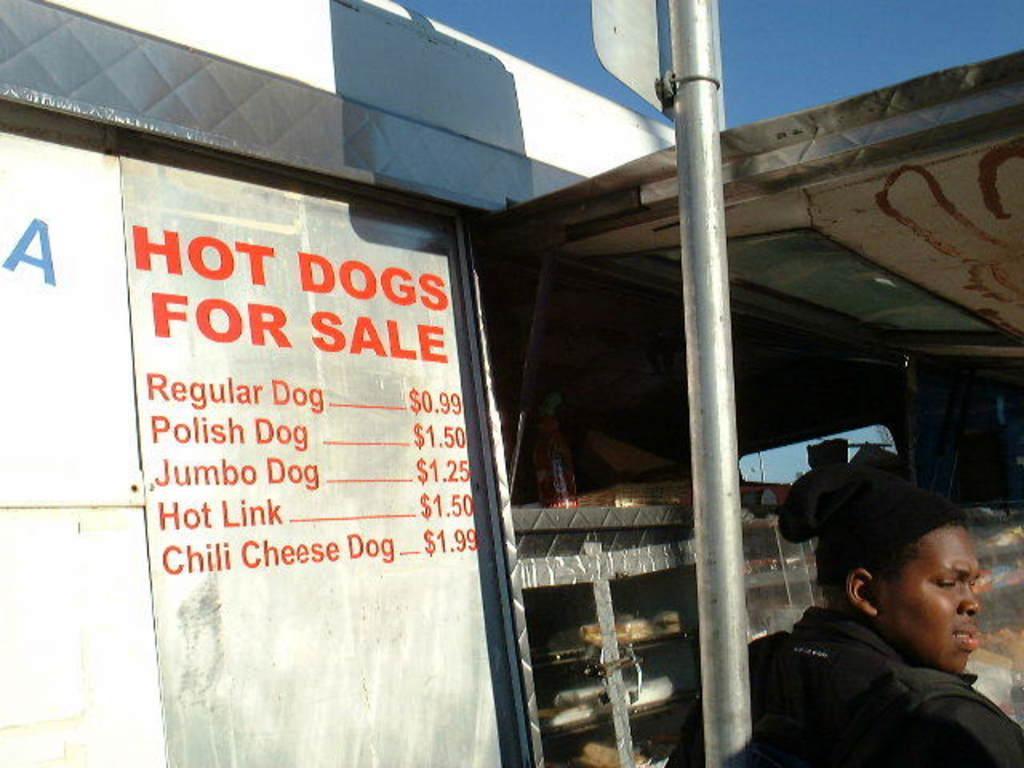Please provide a concise description of this image. In this image I can see the person and the person is wearing black color dress. In the background I can see the stall and the sky is in blue color. 